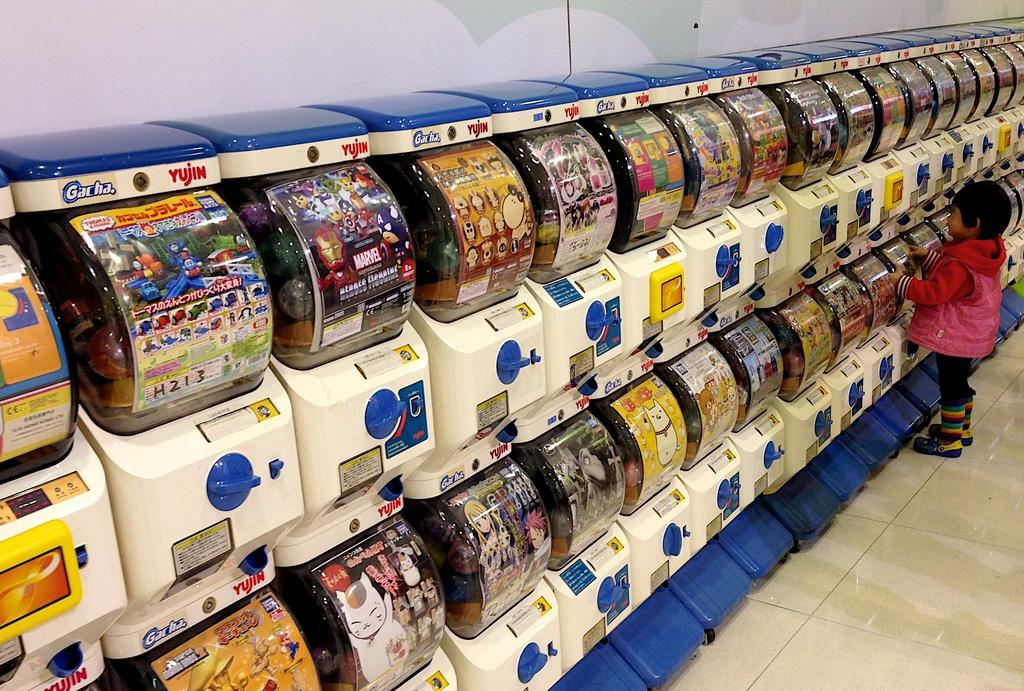<image>
Describe the image concisely. rows of coin machines with the word 'gacha,' on one of them 